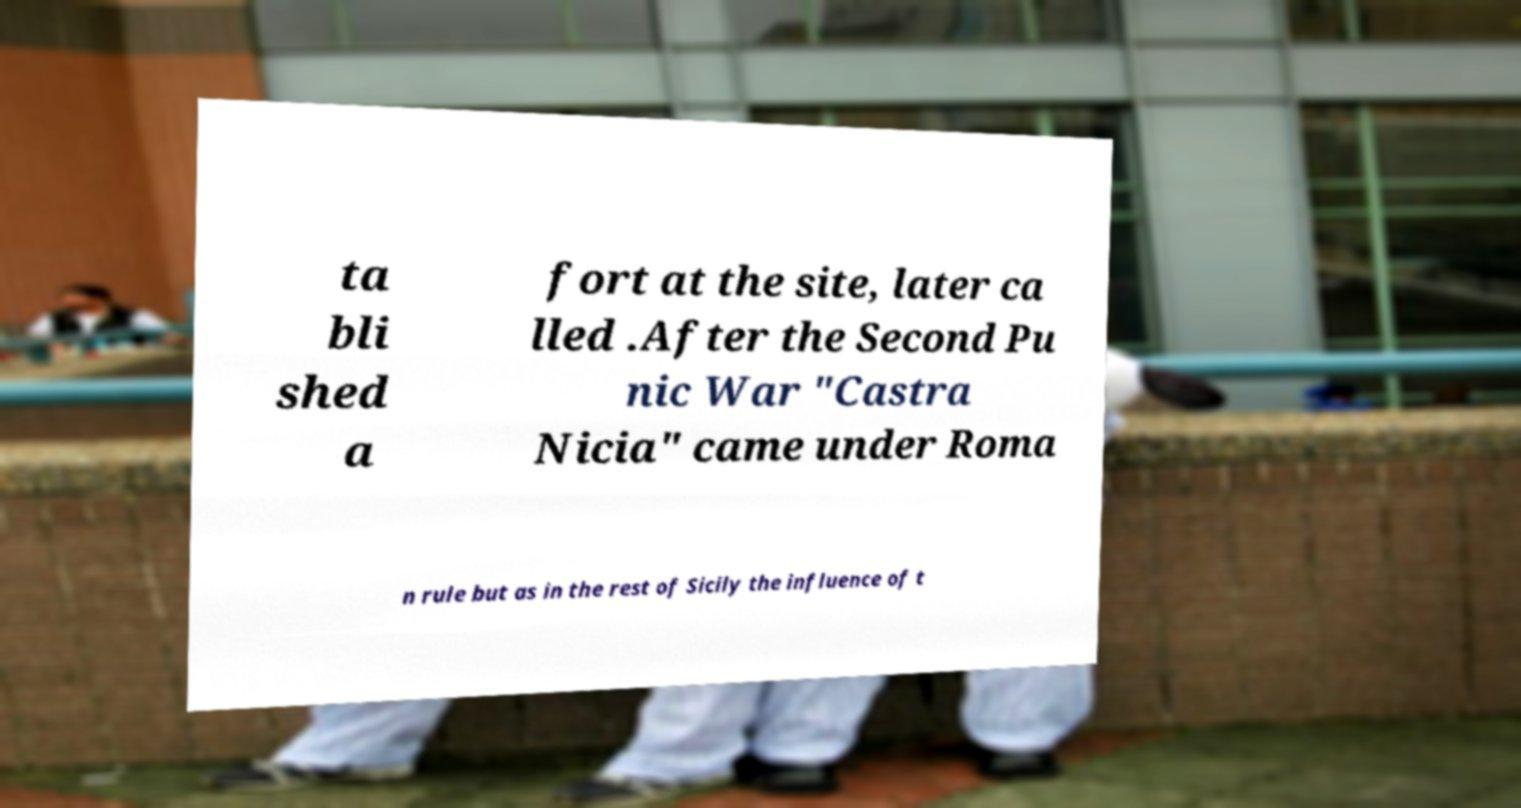I need the written content from this picture converted into text. Can you do that? ta bli shed a fort at the site, later ca lled .After the Second Pu nic War "Castra Nicia" came under Roma n rule but as in the rest of Sicily the influence of t 